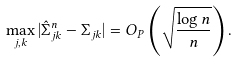Convert formula to latex. <formula><loc_0><loc_0><loc_500><loc_500>\max _ { j , k } | \hat { \Sigma } ^ { n } _ { j k } - \Sigma _ { j k } | = O _ { P } \left ( \sqrt { \frac { \log n } { n } } \right ) .</formula> 